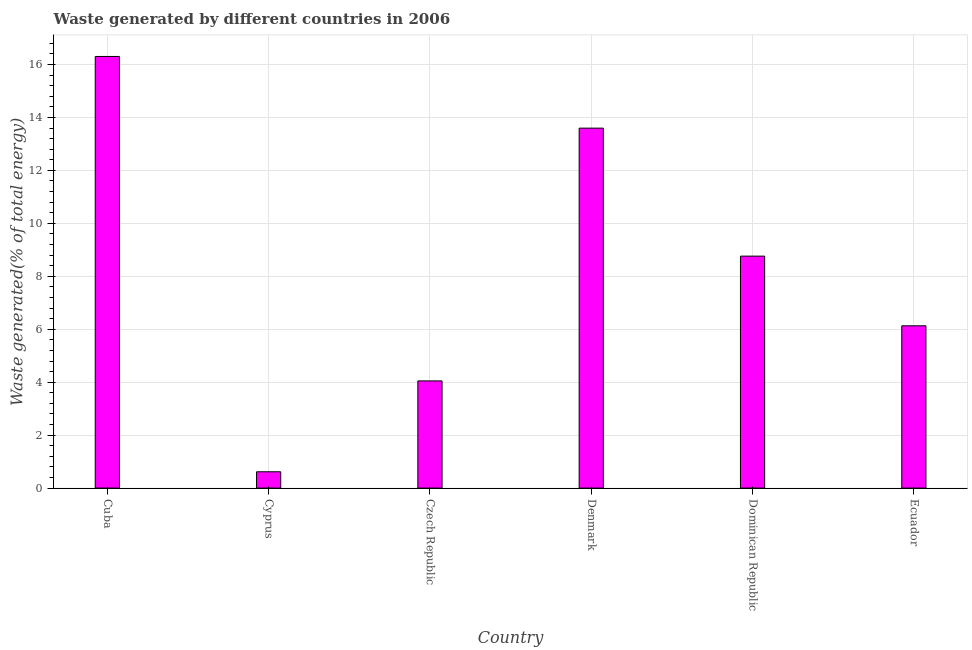Does the graph contain any zero values?
Offer a terse response. No. What is the title of the graph?
Ensure brevity in your answer.  Waste generated by different countries in 2006. What is the label or title of the X-axis?
Provide a short and direct response. Country. What is the label or title of the Y-axis?
Your response must be concise. Waste generated(% of total energy). What is the amount of waste generated in Czech Republic?
Ensure brevity in your answer.  4.05. Across all countries, what is the maximum amount of waste generated?
Your answer should be very brief. 16.3. Across all countries, what is the minimum amount of waste generated?
Your response must be concise. 0.62. In which country was the amount of waste generated maximum?
Make the answer very short. Cuba. In which country was the amount of waste generated minimum?
Keep it short and to the point. Cyprus. What is the sum of the amount of waste generated?
Your answer should be very brief. 49.45. What is the difference between the amount of waste generated in Cyprus and Czech Republic?
Provide a short and direct response. -3.43. What is the average amount of waste generated per country?
Provide a short and direct response. 8.24. What is the median amount of waste generated?
Ensure brevity in your answer.  7.45. In how many countries, is the amount of waste generated greater than 8.4 %?
Offer a terse response. 3. What is the ratio of the amount of waste generated in Cuba to that in Ecuador?
Provide a short and direct response. 2.66. Is the amount of waste generated in Cyprus less than that in Denmark?
Provide a succinct answer. Yes. Is the difference between the amount of waste generated in Cuba and Denmark greater than the difference between any two countries?
Provide a succinct answer. No. What is the difference between the highest and the second highest amount of waste generated?
Make the answer very short. 2.71. Is the sum of the amount of waste generated in Cyprus and Czech Republic greater than the maximum amount of waste generated across all countries?
Keep it short and to the point. No. What is the difference between the highest and the lowest amount of waste generated?
Give a very brief answer. 15.69. In how many countries, is the amount of waste generated greater than the average amount of waste generated taken over all countries?
Keep it short and to the point. 3. How many bars are there?
Make the answer very short. 6. Are all the bars in the graph horizontal?
Offer a very short reply. No. How many countries are there in the graph?
Offer a terse response. 6. Are the values on the major ticks of Y-axis written in scientific E-notation?
Keep it short and to the point. No. What is the Waste generated(% of total energy) of Cuba?
Offer a very short reply. 16.3. What is the Waste generated(% of total energy) in Cyprus?
Keep it short and to the point. 0.62. What is the Waste generated(% of total energy) of Czech Republic?
Give a very brief answer. 4.05. What is the Waste generated(% of total energy) in Denmark?
Ensure brevity in your answer.  13.6. What is the Waste generated(% of total energy) in Dominican Republic?
Your answer should be compact. 8.76. What is the Waste generated(% of total energy) of Ecuador?
Offer a very short reply. 6.13. What is the difference between the Waste generated(% of total energy) in Cuba and Cyprus?
Offer a terse response. 15.69. What is the difference between the Waste generated(% of total energy) in Cuba and Czech Republic?
Provide a short and direct response. 12.26. What is the difference between the Waste generated(% of total energy) in Cuba and Denmark?
Your answer should be compact. 2.71. What is the difference between the Waste generated(% of total energy) in Cuba and Dominican Republic?
Give a very brief answer. 7.54. What is the difference between the Waste generated(% of total energy) in Cuba and Ecuador?
Make the answer very short. 10.17. What is the difference between the Waste generated(% of total energy) in Cyprus and Czech Republic?
Your answer should be compact. -3.43. What is the difference between the Waste generated(% of total energy) in Cyprus and Denmark?
Your answer should be compact. -12.98. What is the difference between the Waste generated(% of total energy) in Cyprus and Dominican Republic?
Give a very brief answer. -8.15. What is the difference between the Waste generated(% of total energy) in Cyprus and Ecuador?
Give a very brief answer. -5.51. What is the difference between the Waste generated(% of total energy) in Czech Republic and Denmark?
Offer a terse response. -9.55. What is the difference between the Waste generated(% of total energy) in Czech Republic and Dominican Republic?
Keep it short and to the point. -4.71. What is the difference between the Waste generated(% of total energy) in Czech Republic and Ecuador?
Provide a succinct answer. -2.08. What is the difference between the Waste generated(% of total energy) in Denmark and Dominican Republic?
Keep it short and to the point. 4.83. What is the difference between the Waste generated(% of total energy) in Denmark and Ecuador?
Provide a short and direct response. 7.47. What is the difference between the Waste generated(% of total energy) in Dominican Republic and Ecuador?
Ensure brevity in your answer.  2.63. What is the ratio of the Waste generated(% of total energy) in Cuba to that in Cyprus?
Offer a very short reply. 26.47. What is the ratio of the Waste generated(% of total energy) in Cuba to that in Czech Republic?
Ensure brevity in your answer.  4.03. What is the ratio of the Waste generated(% of total energy) in Cuba to that in Denmark?
Offer a terse response. 1.2. What is the ratio of the Waste generated(% of total energy) in Cuba to that in Dominican Republic?
Your answer should be compact. 1.86. What is the ratio of the Waste generated(% of total energy) in Cuba to that in Ecuador?
Give a very brief answer. 2.66. What is the ratio of the Waste generated(% of total energy) in Cyprus to that in Czech Republic?
Give a very brief answer. 0.15. What is the ratio of the Waste generated(% of total energy) in Cyprus to that in Denmark?
Ensure brevity in your answer.  0.04. What is the ratio of the Waste generated(% of total energy) in Cyprus to that in Dominican Republic?
Provide a succinct answer. 0.07. What is the ratio of the Waste generated(% of total energy) in Cyprus to that in Ecuador?
Your answer should be very brief. 0.1. What is the ratio of the Waste generated(% of total energy) in Czech Republic to that in Denmark?
Offer a terse response. 0.3. What is the ratio of the Waste generated(% of total energy) in Czech Republic to that in Dominican Republic?
Ensure brevity in your answer.  0.46. What is the ratio of the Waste generated(% of total energy) in Czech Republic to that in Ecuador?
Give a very brief answer. 0.66. What is the ratio of the Waste generated(% of total energy) in Denmark to that in Dominican Republic?
Your answer should be very brief. 1.55. What is the ratio of the Waste generated(% of total energy) in Denmark to that in Ecuador?
Provide a short and direct response. 2.22. What is the ratio of the Waste generated(% of total energy) in Dominican Republic to that in Ecuador?
Give a very brief answer. 1.43. 